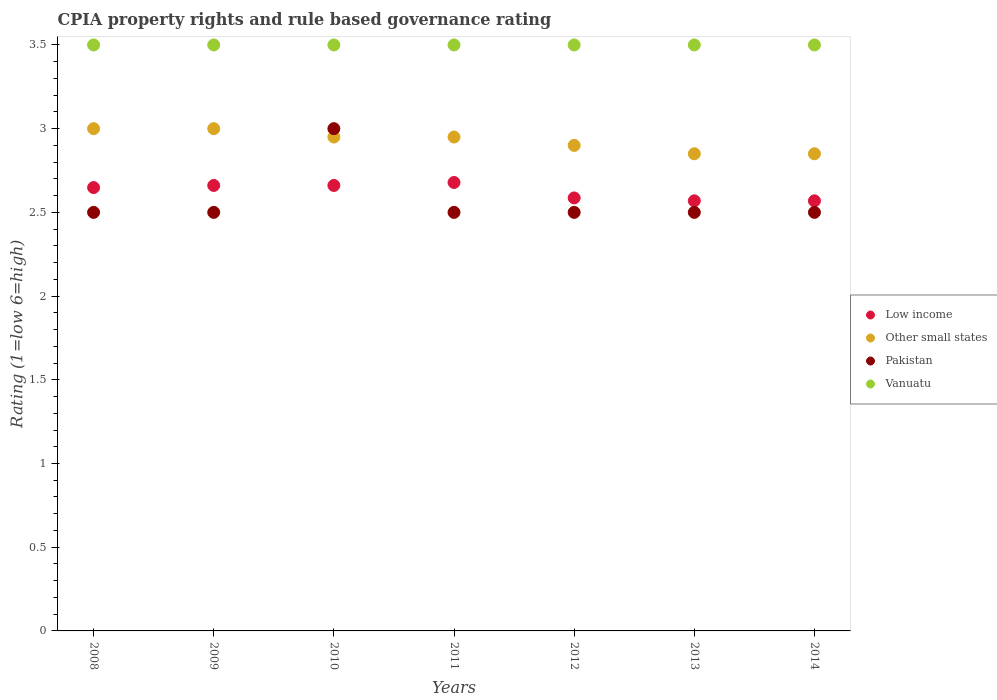How many different coloured dotlines are there?
Provide a short and direct response. 4. What is the CPIA rating in Pakistan in 2010?
Give a very brief answer. 3. Across all years, what is the maximum CPIA rating in Other small states?
Ensure brevity in your answer.  3. What is the total CPIA rating in Pakistan in the graph?
Your answer should be compact. 18. What is the difference between the CPIA rating in Low income in 2009 and that in 2011?
Make the answer very short. -0.02. What is the difference between the CPIA rating in Pakistan in 2013 and the CPIA rating in Vanuatu in 2009?
Offer a terse response. -1. What is the average CPIA rating in Pakistan per year?
Ensure brevity in your answer.  2.57. What is the difference between the highest and the second highest CPIA rating in Pakistan?
Your response must be concise. 0.5. What is the difference between the highest and the lowest CPIA rating in Pakistan?
Your answer should be very brief. 0.5. In how many years, is the CPIA rating in Vanuatu greater than the average CPIA rating in Vanuatu taken over all years?
Provide a short and direct response. 0. Is the sum of the CPIA rating in Vanuatu in 2009 and 2010 greater than the maximum CPIA rating in Other small states across all years?
Provide a succinct answer. Yes. Is the CPIA rating in Vanuatu strictly greater than the CPIA rating in Low income over the years?
Ensure brevity in your answer.  Yes. How many dotlines are there?
Provide a short and direct response. 4. Does the graph contain any zero values?
Offer a terse response. No. Where does the legend appear in the graph?
Your answer should be compact. Center right. How many legend labels are there?
Offer a very short reply. 4. How are the legend labels stacked?
Make the answer very short. Vertical. What is the title of the graph?
Keep it short and to the point. CPIA property rights and rule based governance rating. Does "Togo" appear as one of the legend labels in the graph?
Give a very brief answer. No. What is the label or title of the X-axis?
Provide a succinct answer. Years. What is the label or title of the Y-axis?
Your answer should be very brief. Rating (1=low 6=high). What is the Rating (1=low 6=high) of Low income in 2008?
Keep it short and to the point. 2.65. What is the Rating (1=low 6=high) of Vanuatu in 2008?
Ensure brevity in your answer.  3.5. What is the Rating (1=low 6=high) in Low income in 2009?
Your response must be concise. 2.66. What is the Rating (1=low 6=high) in Pakistan in 2009?
Your answer should be compact. 2.5. What is the Rating (1=low 6=high) of Low income in 2010?
Offer a very short reply. 2.66. What is the Rating (1=low 6=high) in Other small states in 2010?
Give a very brief answer. 2.95. What is the Rating (1=low 6=high) of Pakistan in 2010?
Keep it short and to the point. 3. What is the Rating (1=low 6=high) in Low income in 2011?
Provide a short and direct response. 2.68. What is the Rating (1=low 6=high) of Other small states in 2011?
Provide a short and direct response. 2.95. What is the Rating (1=low 6=high) of Pakistan in 2011?
Give a very brief answer. 2.5. What is the Rating (1=low 6=high) in Vanuatu in 2011?
Your answer should be compact. 3.5. What is the Rating (1=low 6=high) in Low income in 2012?
Your answer should be compact. 2.59. What is the Rating (1=low 6=high) of Other small states in 2012?
Ensure brevity in your answer.  2.9. What is the Rating (1=low 6=high) of Pakistan in 2012?
Make the answer very short. 2.5. What is the Rating (1=low 6=high) of Vanuatu in 2012?
Keep it short and to the point. 3.5. What is the Rating (1=low 6=high) of Low income in 2013?
Make the answer very short. 2.57. What is the Rating (1=low 6=high) of Other small states in 2013?
Keep it short and to the point. 2.85. What is the Rating (1=low 6=high) of Pakistan in 2013?
Your answer should be compact. 2.5. What is the Rating (1=low 6=high) of Low income in 2014?
Your answer should be very brief. 2.57. What is the Rating (1=low 6=high) in Other small states in 2014?
Provide a short and direct response. 2.85. Across all years, what is the maximum Rating (1=low 6=high) in Low income?
Offer a terse response. 2.68. Across all years, what is the maximum Rating (1=low 6=high) of Vanuatu?
Offer a very short reply. 3.5. Across all years, what is the minimum Rating (1=low 6=high) in Low income?
Provide a short and direct response. 2.57. Across all years, what is the minimum Rating (1=low 6=high) of Other small states?
Your answer should be very brief. 2.85. Across all years, what is the minimum Rating (1=low 6=high) in Pakistan?
Offer a terse response. 2.5. Across all years, what is the minimum Rating (1=low 6=high) in Vanuatu?
Provide a succinct answer. 3.5. What is the total Rating (1=low 6=high) of Low income in the graph?
Your answer should be compact. 18.37. What is the total Rating (1=low 6=high) in Vanuatu in the graph?
Provide a short and direct response. 24.5. What is the difference between the Rating (1=low 6=high) of Low income in 2008 and that in 2009?
Your answer should be compact. -0.01. What is the difference between the Rating (1=low 6=high) in Other small states in 2008 and that in 2009?
Give a very brief answer. 0. What is the difference between the Rating (1=low 6=high) in Pakistan in 2008 and that in 2009?
Provide a succinct answer. 0. What is the difference between the Rating (1=low 6=high) of Low income in 2008 and that in 2010?
Your answer should be compact. -0.01. What is the difference between the Rating (1=low 6=high) of Vanuatu in 2008 and that in 2010?
Provide a short and direct response. 0. What is the difference between the Rating (1=low 6=high) in Low income in 2008 and that in 2011?
Your response must be concise. -0.03. What is the difference between the Rating (1=low 6=high) in Low income in 2008 and that in 2012?
Keep it short and to the point. 0.06. What is the difference between the Rating (1=low 6=high) of Other small states in 2008 and that in 2012?
Your response must be concise. 0.1. What is the difference between the Rating (1=low 6=high) in Pakistan in 2008 and that in 2012?
Provide a short and direct response. 0. What is the difference between the Rating (1=low 6=high) of Low income in 2008 and that in 2013?
Your answer should be very brief. 0.08. What is the difference between the Rating (1=low 6=high) in Other small states in 2008 and that in 2013?
Make the answer very short. 0.15. What is the difference between the Rating (1=low 6=high) in Pakistan in 2008 and that in 2013?
Offer a terse response. 0. What is the difference between the Rating (1=low 6=high) in Vanuatu in 2008 and that in 2013?
Provide a short and direct response. 0. What is the difference between the Rating (1=low 6=high) of Low income in 2008 and that in 2014?
Your answer should be compact. 0.08. What is the difference between the Rating (1=low 6=high) in Pakistan in 2008 and that in 2014?
Make the answer very short. 0. What is the difference between the Rating (1=low 6=high) in Pakistan in 2009 and that in 2010?
Ensure brevity in your answer.  -0.5. What is the difference between the Rating (1=low 6=high) of Low income in 2009 and that in 2011?
Provide a succinct answer. -0.02. What is the difference between the Rating (1=low 6=high) of Low income in 2009 and that in 2012?
Offer a terse response. 0.07. What is the difference between the Rating (1=low 6=high) of Vanuatu in 2009 and that in 2012?
Ensure brevity in your answer.  0. What is the difference between the Rating (1=low 6=high) of Low income in 2009 and that in 2013?
Offer a very short reply. 0.09. What is the difference between the Rating (1=low 6=high) in Other small states in 2009 and that in 2013?
Offer a terse response. 0.15. What is the difference between the Rating (1=low 6=high) in Low income in 2009 and that in 2014?
Offer a very short reply. 0.09. What is the difference between the Rating (1=low 6=high) of Pakistan in 2009 and that in 2014?
Your answer should be compact. 0. What is the difference between the Rating (1=low 6=high) of Low income in 2010 and that in 2011?
Keep it short and to the point. -0.02. What is the difference between the Rating (1=low 6=high) of Other small states in 2010 and that in 2011?
Your answer should be very brief. 0. What is the difference between the Rating (1=low 6=high) of Vanuatu in 2010 and that in 2011?
Keep it short and to the point. 0. What is the difference between the Rating (1=low 6=high) of Low income in 2010 and that in 2012?
Give a very brief answer. 0.07. What is the difference between the Rating (1=low 6=high) in Other small states in 2010 and that in 2012?
Provide a succinct answer. 0.05. What is the difference between the Rating (1=low 6=high) of Pakistan in 2010 and that in 2012?
Offer a terse response. 0.5. What is the difference between the Rating (1=low 6=high) in Vanuatu in 2010 and that in 2012?
Keep it short and to the point. 0. What is the difference between the Rating (1=low 6=high) in Low income in 2010 and that in 2013?
Ensure brevity in your answer.  0.09. What is the difference between the Rating (1=low 6=high) in Other small states in 2010 and that in 2013?
Provide a short and direct response. 0.1. What is the difference between the Rating (1=low 6=high) of Vanuatu in 2010 and that in 2013?
Your answer should be compact. 0. What is the difference between the Rating (1=low 6=high) in Low income in 2010 and that in 2014?
Your answer should be compact. 0.09. What is the difference between the Rating (1=low 6=high) in Other small states in 2010 and that in 2014?
Offer a very short reply. 0.1. What is the difference between the Rating (1=low 6=high) in Pakistan in 2010 and that in 2014?
Provide a succinct answer. 0.5. What is the difference between the Rating (1=low 6=high) in Low income in 2011 and that in 2012?
Offer a terse response. 0.09. What is the difference between the Rating (1=low 6=high) of Other small states in 2011 and that in 2012?
Your answer should be compact. 0.05. What is the difference between the Rating (1=low 6=high) in Low income in 2011 and that in 2013?
Keep it short and to the point. 0.11. What is the difference between the Rating (1=low 6=high) in Pakistan in 2011 and that in 2013?
Ensure brevity in your answer.  0. What is the difference between the Rating (1=low 6=high) in Vanuatu in 2011 and that in 2013?
Your response must be concise. 0. What is the difference between the Rating (1=low 6=high) in Low income in 2011 and that in 2014?
Ensure brevity in your answer.  0.11. What is the difference between the Rating (1=low 6=high) in Vanuatu in 2011 and that in 2014?
Provide a short and direct response. 0. What is the difference between the Rating (1=low 6=high) in Low income in 2012 and that in 2013?
Your answer should be very brief. 0.02. What is the difference between the Rating (1=low 6=high) in Other small states in 2012 and that in 2013?
Your response must be concise. 0.05. What is the difference between the Rating (1=low 6=high) of Pakistan in 2012 and that in 2013?
Provide a succinct answer. 0. What is the difference between the Rating (1=low 6=high) in Vanuatu in 2012 and that in 2013?
Your answer should be compact. 0. What is the difference between the Rating (1=low 6=high) in Low income in 2012 and that in 2014?
Your answer should be compact. 0.02. What is the difference between the Rating (1=low 6=high) in Pakistan in 2012 and that in 2014?
Provide a succinct answer. 0. What is the difference between the Rating (1=low 6=high) of Vanuatu in 2012 and that in 2014?
Your answer should be compact. 0. What is the difference between the Rating (1=low 6=high) of Other small states in 2013 and that in 2014?
Provide a succinct answer. 0. What is the difference between the Rating (1=low 6=high) of Pakistan in 2013 and that in 2014?
Offer a very short reply. 0. What is the difference between the Rating (1=low 6=high) of Low income in 2008 and the Rating (1=low 6=high) of Other small states in 2009?
Your answer should be compact. -0.35. What is the difference between the Rating (1=low 6=high) in Low income in 2008 and the Rating (1=low 6=high) in Pakistan in 2009?
Keep it short and to the point. 0.15. What is the difference between the Rating (1=low 6=high) in Low income in 2008 and the Rating (1=low 6=high) in Vanuatu in 2009?
Your response must be concise. -0.85. What is the difference between the Rating (1=low 6=high) of Other small states in 2008 and the Rating (1=low 6=high) of Vanuatu in 2009?
Keep it short and to the point. -0.5. What is the difference between the Rating (1=low 6=high) in Low income in 2008 and the Rating (1=low 6=high) in Other small states in 2010?
Give a very brief answer. -0.3. What is the difference between the Rating (1=low 6=high) of Low income in 2008 and the Rating (1=low 6=high) of Pakistan in 2010?
Offer a terse response. -0.35. What is the difference between the Rating (1=low 6=high) in Low income in 2008 and the Rating (1=low 6=high) in Vanuatu in 2010?
Make the answer very short. -0.85. What is the difference between the Rating (1=low 6=high) in Low income in 2008 and the Rating (1=low 6=high) in Other small states in 2011?
Provide a succinct answer. -0.3. What is the difference between the Rating (1=low 6=high) in Low income in 2008 and the Rating (1=low 6=high) in Pakistan in 2011?
Your answer should be very brief. 0.15. What is the difference between the Rating (1=low 6=high) of Low income in 2008 and the Rating (1=low 6=high) of Vanuatu in 2011?
Keep it short and to the point. -0.85. What is the difference between the Rating (1=low 6=high) of Pakistan in 2008 and the Rating (1=low 6=high) of Vanuatu in 2011?
Give a very brief answer. -1. What is the difference between the Rating (1=low 6=high) in Low income in 2008 and the Rating (1=low 6=high) in Other small states in 2012?
Your answer should be very brief. -0.25. What is the difference between the Rating (1=low 6=high) of Low income in 2008 and the Rating (1=low 6=high) of Pakistan in 2012?
Make the answer very short. 0.15. What is the difference between the Rating (1=low 6=high) in Low income in 2008 and the Rating (1=low 6=high) in Vanuatu in 2012?
Offer a terse response. -0.85. What is the difference between the Rating (1=low 6=high) of Other small states in 2008 and the Rating (1=low 6=high) of Vanuatu in 2012?
Offer a very short reply. -0.5. What is the difference between the Rating (1=low 6=high) of Pakistan in 2008 and the Rating (1=low 6=high) of Vanuatu in 2012?
Ensure brevity in your answer.  -1. What is the difference between the Rating (1=low 6=high) of Low income in 2008 and the Rating (1=low 6=high) of Other small states in 2013?
Keep it short and to the point. -0.2. What is the difference between the Rating (1=low 6=high) in Low income in 2008 and the Rating (1=low 6=high) in Pakistan in 2013?
Keep it short and to the point. 0.15. What is the difference between the Rating (1=low 6=high) in Low income in 2008 and the Rating (1=low 6=high) in Vanuatu in 2013?
Provide a succinct answer. -0.85. What is the difference between the Rating (1=low 6=high) of Pakistan in 2008 and the Rating (1=low 6=high) of Vanuatu in 2013?
Ensure brevity in your answer.  -1. What is the difference between the Rating (1=low 6=high) in Low income in 2008 and the Rating (1=low 6=high) in Other small states in 2014?
Make the answer very short. -0.2. What is the difference between the Rating (1=low 6=high) of Low income in 2008 and the Rating (1=low 6=high) of Pakistan in 2014?
Your answer should be very brief. 0.15. What is the difference between the Rating (1=low 6=high) of Low income in 2008 and the Rating (1=low 6=high) of Vanuatu in 2014?
Your answer should be compact. -0.85. What is the difference between the Rating (1=low 6=high) of Other small states in 2008 and the Rating (1=low 6=high) of Pakistan in 2014?
Ensure brevity in your answer.  0.5. What is the difference between the Rating (1=low 6=high) in Other small states in 2008 and the Rating (1=low 6=high) in Vanuatu in 2014?
Offer a very short reply. -0.5. What is the difference between the Rating (1=low 6=high) of Low income in 2009 and the Rating (1=low 6=high) of Other small states in 2010?
Provide a succinct answer. -0.29. What is the difference between the Rating (1=low 6=high) in Low income in 2009 and the Rating (1=low 6=high) in Pakistan in 2010?
Provide a short and direct response. -0.34. What is the difference between the Rating (1=low 6=high) in Low income in 2009 and the Rating (1=low 6=high) in Vanuatu in 2010?
Make the answer very short. -0.84. What is the difference between the Rating (1=low 6=high) of Other small states in 2009 and the Rating (1=low 6=high) of Pakistan in 2010?
Your response must be concise. 0. What is the difference between the Rating (1=low 6=high) of Low income in 2009 and the Rating (1=low 6=high) of Other small states in 2011?
Your answer should be compact. -0.29. What is the difference between the Rating (1=low 6=high) of Low income in 2009 and the Rating (1=low 6=high) of Pakistan in 2011?
Provide a succinct answer. 0.16. What is the difference between the Rating (1=low 6=high) of Low income in 2009 and the Rating (1=low 6=high) of Vanuatu in 2011?
Provide a short and direct response. -0.84. What is the difference between the Rating (1=low 6=high) in Other small states in 2009 and the Rating (1=low 6=high) in Pakistan in 2011?
Give a very brief answer. 0.5. What is the difference between the Rating (1=low 6=high) in Low income in 2009 and the Rating (1=low 6=high) in Other small states in 2012?
Keep it short and to the point. -0.24. What is the difference between the Rating (1=low 6=high) of Low income in 2009 and the Rating (1=low 6=high) of Pakistan in 2012?
Provide a short and direct response. 0.16. What is the difference between the Rating (1=low 6=high) in Low income in 2009 and the Rating (1=low 6=high) in Vanuatu in 2012?
Your response must be concise. -0.84. What is the difference between the Rating (1=low 6=high) of Low income in 2009 and the Rating (1=low 6=high) of Other small states in 2013?
Offer a terse response. -0.19. What is the difference between the Rating (1=low 6=high) in Low income in 2009 and the Rating (1=low 6=high) in Pakistan in 2013?
Ensure brevity in your answer.  0.16. What is the difference between the Rating (1=low 6=high) of Low income in 2009 and the Rating (1=low 6=high) of Vanuatu in 2013?
Keep it short and to the point. -0.84. What is the difference between the Rating (1=low 6=high) in Other small states in 2009 and the Rating (1=low 6=high) in Pakistan in 2013?
Offer a very short reply. 0.5. What is the difference between the Rating (1=low 6=high) of Pakistan in 2009 and the Rating (1=low 6=high) of Vanuatu in 2013?
Give a very brief answer. -1. What is the difference between the Rating (1=low 6=high) of Low income in 2009 and the Rating (1=low 6=high) of Other small states in 2014?
Give a very brief answer. -0.19. What is the difference between the Rating (1=low 6=high) of Low income in 2009 and the Rating (1=low 6=high) of Pakistan in 2014?
Offer a terse response. 0.16. What is the difference between the Rating (1=low 6=high) of Low income in 2009 and the Rating (1=low 6=high) of Vanuatu in 2014?
Provide a succinct answer. -0.84. What is the difference between the Rating (1=low 6=high) in Other small states in 2009 and the Rating (1=low 6=high) in Pakistan in 2014?
Provide a short and direct response. 0.5. What is the difference between the Rating (1=low 6=high) in Low income in 2010 and the Rating (1=low 6=high) in Other small states in 2011?
Your response must be concise. -0.29. What is the difference between the Rating (1=low 6=high) in Low income in 2010 and the Rating (1=low 6=high) in Pakistan in 2011?
Offer a terse response. 0.16. What is the difference between the Rating (1=low 6=high) in Low income in 2010 and the Rating (1=low 6=high) in Vanuatu in 2011?
Your answer should be very brief. -0.84. What is the difference between the Rating (1=low 6=high) in Other small states in 2010 and the Rating (1=low 6=high) in Pakistan in 2011?
Your answer should be very brief. 0.45. What is the difference between the Rating (1=low 6=high) in Other small states in 2010 and the Rating (1=low 6=high) in Vanuatu in 2011?
Your answer should be compact. -0.55. What is the difference between the Rating (1=low 6=high) of Low income in 2010 and the Rating (1=low 6=high) of Other small states in 2012?
Offer a very short reply. -0.24. What is the difference between the Rating (1=low 6=high) of Low income in 2010 and the Rating (1=low 6=high) of Pakistan in 2012?
Your answer should be very brief. 0.16. What is the difference between the Rating (1=low 6=high) of Low income in 2010 and the Rating (1=low 6=high) of Vanuatu in 2012?
Your answer should be compact. -0.84. What is the difference between the Rating (1=low 6=high) in Other small states in 2010 and the Rating (1=low 6=high) in Pakistan in 2012?
Offer a terse response. 0.45. What is the difference between the Rating (1=low 6=high) in Other small states in 2010 and the Rating (1=low 6=high) in Vanuatu in 2012?
Offer a terse response. -0.55. What is the difference between the Rating (1=low 6=high) of Pakistan in 2010 and the Rating (1=low 6=high) of Vanuatu in 2012?
Keep it short and to the point. -0.5. What is the difference between the Rating (1=low 6=high) of Low income in 2010 and the Rating (1=low 6=high) of Other small states in 2013?
Make the answer very short. -0.19. What is the difference between the Rating (1=low 6=high) of Low income in 2010 and the Rating (1=low 6=high) of Pakistan in 2013?
Offer a very short reply. 0.16. What is the difference between the Rating (1=low 6=high) in Low income in 2010 and the Rating (1=low 6=high) in Vanuatu in 2013?
Give a very brief answer. -0.84. What is the difference between the Rating (1=low 6=high) in Other small states in 2010 and the Rating (1=low 6=high) in Pakistan in 2013?
Your answer should be very brief. 0.45. What is the difference between the Rating (1=low 6=high) in Other small states in 2010 and the Rating (1=low 6=high) in Vanuatu in 2013?
Your response must be concise. -0.55. What is the difference between the Rating (1=low 6=high) of Pakistan in 2010 and the Rating (1=low 6=high) of Vanuatu in 2013?
Your answer should be very brief. -0.5. What is the difference between the Rating (1=low 6=high) of Low income in 2010 and the Rating (1=low 6=high) of Other small states in 2014?
Offer a terse response. -0.19. What is the difference between the Rating (1=low 6=high) in Low income in 2010 and the Rating (1=low 6=high) in Pakistan in 2014?
Offer a very short reply. 0.16. What is the difference between the Rating (1=low 6=high) of Low income in 2010 and the Rating (1=low 6=high) of Vanuatu in 2014?
Give a very brief answer. -0.84. What is the difference between the Rating (1=low 6=high) of Other small states in 2010 and the Rating (1=low 6=high) of Pakistan in 2014?
Your response must be concise. 0.45. What is the difference between the Rating (1=low 6=high) of Other small states in 2010 and the Rating (1=low 6=high) of Vanuatu in 2014?
Give a very brief answer. -0.55. What is the difference between the Rating (1=low 6=high) of Low income in 2011 and the Rating (1=low 6=high) of Other small states in 2012?
Offer a terse response. -0.22. What is the difference between the Rating (1=low 6=high) of Low income in 2011 and the Rating (1=low 6=high) of Pakistan in 2012?
Provide a succinct answer. 0.18. What is the difference between the Rating (1=low 6=high) in Low income in 2011 and the Rating (1=low 6=high) in Vanuatu in 2012?
Provide a succinct answer. -0.82. What is the difference between the Rating (1=low 6=high) in Other small states in 2011 and the Rating (1=low 6=high) in Pakistan in 2012?
Make the answer very short. 0.45. What is the difference between the Rating (1=low 6=high) of Other small states in 2011 and the Rating (1=low 6=high) of Vanuatu in 2012?
Ensure brevity in your answer.  -0.55. What is the difference between the Rating (1=low 6=high) in Pakistan in 2011 and the Rating (1=low 6=high) in Vanuatu in 2012?
Give a very brief answer. -1. What is the difference between the Rating (1=low 6=high) in Low income in 2011 and the Rating (1=low 6=high) in Other small states in 2013?
Your answer should be compact. -0.17. What is the difference between the Rating (1=low 6=high) in Low income in 2011 and the Rating (1=low 6=high) in Pakistan in 2013?
Keep it short and to the point. 0.18. What is the difference between the Rating (1=low 6=high) in Low income in 2011 and the Rating (1=low 6=high) in Vanuatu in 2013?
Give a very brief answer. -0.82. What is the difference between the Rating (1=low 6=high) of Other small states in 2011 and the Rating (1=low 6=high) of Pakistan in 2013?
Offer a very short reply. 0.45. What is the difference between the Rating (1=low 6=high) of Other small states in 2011 and the Rating (1=low 6=high) of Vanuatu in 2013?
Your answer should be very brief. -0.55. What is the difference between the Rating (1=low 6=high) in Low income in 2011 and the Rating (1=low 6=high) in Other small states in 2014?
Give a very brief answer. -0.17. What is the difference between the Rating (1=low 6=high) of Low income in 2011 and the Rating (1=low 6=high) of Pakistan in 2014?
Your answer should be compact. 0.18. What is the difference between the Rating (1=low 6=high) of Low income in 2011 and the Rating (1=low 6=high) of Vanuatu in 2014?
Give a very brief answer. -0.82. What is the difference between the Rating (1=low 6=high) of Other small states in 2011 and the Rating (1=low 6=high) of Pakistan in 2014?
Offer a very short reply. 0.45. What is the difference between the Rating (1=low 6=high) of Other small states in 2011 and the Rating (1=low 6=high) of Vanuatu in 2014?
Provide a short and direct response. -0.55. What is the difference between the Rating (1=low 6=high) in Pakistan in 2011 and the Rating (1=low 6=high) in Vanuatu in 2014?
Offer a very short reply. -1. What is the difference between the Rating (1=low 6=high) of Low income in 2012 and the Rating (1=low 6=high) of Other small states in 2013?
Ensure brevity in your answer.  -0.26. What is the difference between the Rating (1=low 6=high) of Low income in 2012 and the Rating (1=low 6=high) of Pakistan in 2013?
Offer a terse response. 0.09. What is the difference between the Rating (1=low 6=high) of Low income in 2012 and the Rating (1=low 6=high) of Vanuatu in 2013?
Provide a short and direct response. -0.91. What is the difference between the Rating (1=low 6=high) of Other small states in 2012 and the Rating (1=low 6=high) of Pakistan in 2013?
Make the answer very short. 0.4. What is the difference between the Rating (1=low 6=high) in Low income in 2012 and the Rating (1=low 6=high) in Other small states in 2014?
Give a very brief answer. -0.26. What is the difference between the Rating (1=low 6=high) of Low income in 2012 and the Rating (1=low 6=high) of Pakistan in 2014?
Offer a terse response. 0.09. What is the difference between the Rating (1=low 6=high) in Low income in 2012 and the Rating (1=low 6=high) in Vanuatu in 2014?
Your answer should be compact. -0.91. What is the difference between the Rating (1=low 6=high) of Other small states in 2012 and the Rating (1=low 6=high) of Vanuatu in 2014?
Offer a terse response. -0.6. What is the difference between the Rating (1=low 6=high) of Low income in 2013 and the Rating (1=low 6=high) of Other small states in 2014?
Offer a terse response. -0.28. What is the difference between the Rating (1=low 6=high) in Low income in 2013 and the Rating (1=low 6=high) in Pakistan in 2014?
Make the answer very short. 0.07. What is the difference between the Rating (1=low 6=high) of Low income in 2013 and the Rating (1=low 6=high) of Vanuatu in 2014?
Your response must be concise. -0.93. What is the difference between the Rating (1=low 6=high) of Other small states in 2013 and the Rating (1=low 6=high) of Vanuatu in 2014?
Your response must be concise. -0.65. What is the average Rating (1=low 6=high) of Low income per year?
Provide a short and direct response. 2.62. What is the average Rating (1=low 6=high) of Other small states per year?
Give a very brief answer. 2.93. What is the average Rating (1=low 6=high) in Pakistan per year?
Make the answer very short. 2.57. In the year 2008, what is the difference between the Rating (1=low 6=high) in Low income and Rating (1=low 6=high) in Other small states?
Keep it short and to the point. -0.35. In the year 2008, what is the difference between the Rating (1=low 6=high) in Low income and Rating (1=low 6=high) in Pakistan?
Ensure brevity in your answer.  0.15. In the year 2008, what is the difference between the Rating (1=low 6=high) of Low income and Rating (1=low 6=high) of Vanuatu?
Your response must be concise. -0.85. In the year 2009, what is the difference between the Rating (1=low 6=high) in Low income and Rating (1=low 6=high) in Other small states?
Ensure brevity in your answer.  -0.34. In the year 2009, what is the difference between the Rating (1=low 6=high) in Low income and Rating (1=low 6=high) in Pakistan?
Provide a short and direct response. 0.16. In the year 2009, what is the difference between the Rating (1=low 6=high) of Low income and Rating (1=low 6=high) of Vanuatu?
Offer a terse response. -0.84. In the year 2009, what is the difference between the Rating (1=low 6=high) in Other small states and Rating (1=low 6=high) in Pakistan?
Provide a succinct answer. 0.5. In the year 2009, what is the difference between the Rating (1=low 6=high) in Other small states and Rating (1=low 6=high) in Vanuatu?
Offer a terse response. -0.5. In the year 2010, what is the difference between the Rating (1=low 6=high) in Low income and Rating (1=low 6=high) in Other small states?
Your answer should be very brief. -0.29. In the year 2010, what is the difference between the Rating (1=low 6=high) in Low income and Rating (1=low 6=high) in Pakistan?
Your answer should be very brief. -0.34. In the year 2010, what is the difference between the Rating (1=low 6=high) of Low income and Rating (1=low 6=high) of Vanuatu?
Provide a short and direct response. -0.84. In the year 2010, what is the difference between the Rating (1=low 6=high) of Other small states and Rating (1=low 6=high) of Pakistan?
Your response must be concise. -0.05. In the year 2010, what is the difference between the Rating (1=low 6=high) in Other small states and Rating (1=low 6=high) in Vanuatu?
Ensure brevity in your answer.  -0.55. In the year 2011, what is the difference between the Rating (1=low 6=high) of Low income and Rating (1=low 6=high) of Other small states?
Your response must be concise. -0.27. In the year 2011, what is the difference between the Rating (1=low 6=high) of Low income and Rating (1=low 6=high) of Pakistan?
Your answer should be very brief. 0.18. In the year 2011, what is the difference between the Rating (1=low 6=high) in Low income and Rating (1=low 6=high) in Vanuatu?
Offer a terse response. -0.82. In the year 2011, what is the difference between the Rating (1=low 6=high) of Other small states and Rating (1=low 6=high) of Pakistan?
Keep it short and to the point. 0.45. In the year 2011, what is the difference between the Rating (1=low 6=high) in Other small states and Rating (1=low 6=high) in Vanuatu?
Provide a succinct answer. -0.55. In the year 2011, what is the difference between the Rating (1=low 6=high) of Pakistan and Rating (1=low 6=high) of Vanuatu?
Keep it short and to the point. -1. In the year 2012, what is the difference between the Rating (1=low 6=high) of Low income and Rating (1=low 6=high) of Other small states?
Your answer should be very brief. -0.31. In the year 2012, what is the difference between the Rating (1=low 6=high) of Low income and Rating (1=low 6=high) of Pakistan?
Offer a very short reply. 0.09. In the year 2012, what is the difference between the Rating (1=low 6=high) of Low income and Rating (1=low 6=high) of Vanuatu?
Ensure brevity in your answer.  -0.91. In the year 2012, what is the difference between the Rating (1=low 6=high) of Other small states and Rating (1=low 6=high) of Pakistan?
Your response must be concise. 0.4. In the year 2012, what is the difference between the Rating (1=low 6=high) in Other small states and Rating (1=low 6=high) in Vanuatu?
Give a very brief answer. -0.6. In the year 2012, what is the difference between the Rating (1=low 6=high) in Pakistan and Rating (1=low 6=high) in Vanuatu?
Provide a short and direct response. -1. In the year 2013, what is the difference between the Rating (1=low 6=high) in Low income and Rating (1=low 6=high) in Other small states?
Your answer should be compact. -0.28. In the year 2013, what is the difference between the Rating (1=low 6=high) of Low income and Rating (1=low 6=high) of Pakistan?
Provide a succinct answer. 0.07. In the year 2013, what is the difference between the Rating (1=low 6=high) in Low income and Rating (1=low 6=high) in Vanuatu?
Offer a very short reply. -0.93. In the year 2013, what is the difference between the Rating (1=low 6=high) in Other small states and Rating (1=low 6=high) in Vanuatu?
Give a very brief answer. -0.65. In the year 2014, what is the difference between the Rating (1=low 6=high) of Low income and Rating (1=low 6=high) of Other small states?
Offer a terse response. -0.28. In the year 2014, what is the difference between the Rating (1=low 6=high) in Low income and Rating (1=low 6=high) in Pakistan?
Ensure brevity in your answer.  0.07. In the year 2014, what is the difference between the Rating (1=low 6=high) in Low income and Rating (1=low 6=high) in Vanuatu?
Your response must be concise. -0.93. In the year 2014, what is the difference between the Rating (1=low 6=high) in Other small states and Rating (1=low 6=high) in Vanuatu?
Ensure brevity in your answer.  -0.65. In the year 2014, what is the difference between the Rating (1=low 6=high) of Pakistan and Rating (1=low 6=high) of Vanuatu?
Your response must be concise. -1. What is the ratio of the Rating (1=low 6=high) in Other small states in 2008 to that in 2009?
Keep it short and to the point. 1. What is the ratio of the Rating (1=low 6=high) of Vanuatu in 2008 to that in 2009?
Your answer should be compact. 1. What is the ratio of the Rating (1=low 6=high) in Other small states in 2008 to that in 2010?
Offer a very short reply. 1.02. What is the ratio of the Rating (1=low 6=high) in Vanuatu in 2008 to that in 2010?
Make the answer very short. 1. What is the ratio of the Rating (1=low 6=high) in Low income in 2008 to that in 2011?
Provide a short and direct response. 0.99. What is the ratio of the Rating (1=low 6=high) of Other small states in 2008 to that in 2011?
Make the answer very short. 1.02. What is the ratio of the Rating (1=low 6=high) of Other small states in 2008 to that in 2012?
Your response must be concise. 1.03. What is the ratio of the Rating (1=low 6=high) of Low income in 2008 to that in 2013?
Provide a succinct answer. 1.03. What is the ratio of the Rating (1=low 6=high) in Other small states in 2008 to that in 2013?
Make the answer very short. 1.05. What is the ratio of the Rating (1=low 6=high) in Vanuatu in 2008 to that in 2013?
Provide a succinct answer. 1. What is the ratio of the Rating (1=low 6=high) of Low income in 2008 to that in 2014?
Provide a succinct answer. 1.03. What is the ratio of the Rating (1=low 6=high) of Other small states in 2008 to that in 2014?
Your answer should be compact. 1.05. What is the ratio of the Rating (1=low 6=high) of Pakistan in 2008 to that in 2014?
Your answer should be very brief. 1. What is the ratio of the Rating (1=low 6=high) of Low income in 2009 to that in 2010?
Provide a succinct answer. 1. What is the ratio of the Rating (1=low 6=high) in Other small states in 2009 to that in 2010?
Your response must be concise. 1.02. What is the ratio of the Rating (1=low 6=high) of Pakistan in 2009 to that in 2010?
Offer a terse response. 0.83. What is the ratio of the Rating (1=low 6=high) of Vanuatu in 2009 to that in 2010?
Give a very brief answer. 1. What is the ratio of the Rating (1=low 6=high) in Low income in 2009 to that in 2011?
Give a very brief answer. 0.99. What is the ratio of the Rating (1=low 6=high) of Other small states in 2009 to that in 2011?
Give a very brief answer. 1.02. What is the ratio of the Rating (1=low 6=high) in Vanuatu in 2009 to that in 2011?
Your answer should be compact. 1. What is the ratio of the Rating (1=low 6=high) of Low income in 2009 to that in 2012?
Offer a very short reply. 1.03. What is the ratio of the Rating (1=low 6=high) in Other small states in 2009 to that in 2012?
Ensure brevity in your answer.  1.03. What is the ratio of the Rating (1=low 6=high) in Pakistan in 2009 to that in 2012?
Offer a terse response. 1. What is the ratio of the Rating (1=low 6=high) of Vanuatu in 2009 to that in 2012?
Offer a very short reply. 1. What is the ratio of the Rating (1=low 6=high) of Low income in 2009 to that in 2013?
Your answer should be very brief. 1.04. What is the ratio of the Rating (1=low 6=high) of Other small states in 2009 to that in 2013?
Offer a terse response. 1.05. What is the ratio of the Rating (1=low 6=high) of Pakistan in 2009 to that in 2013?
Your response must be concise. 1. What is the ratio of the Rating (1=low 6=high) of Low income in 2009 to that in 2014?
Provide a succinct answer. 1.04. What is the ratio of the Rating (1=low 6=high) in Other small states in 2009 to that in 2014?
Offer a terse response. 1.05. What is the ratio of the Rating (1=low 6=high) in Low income in 2010 to that in 2011?
Keep it short and to the point. 0.99. What is the ratio of the Rating (1=low 6=high) in Other small states in 2010 to that in 2011?
Your answer should be very brief. 1. What is the ratio of the Rating (1=low 6=high) of Pakistan in 2010 to that in 2011?
Give a very brief answer. 1.2. What is the ratio of the Rating (1=low 6=high) in Low income in 2010 to that in 2012?
Offer a very short reply. 1.03. What is the ratio of the Rating (1=low 6=high) in Other small states in 2010 to that in 2012?
Keep it short and to the point. 1.02. What is the ratio of the Rating (1=low 6=high) of Pakistan in 2010 to that in 2012?
Provide a succinct answer. 1.2. What is the ratio of the Rating (1=low 6=high) in Vanuatu in 2010 to that in 2012?
Give a very brief answer. 1. What is the ratio of the Rating (1=low 6=high) in Low income in 2010 to that in 2013?
Your answer should be very brief. 1.04. What is the ratio of the Rating (1=low 6=high) in Other small states in 2010 to that in 2013?
Give a very brief answer. 1.04. What is the ratio of the Rating (1=low 6=high) of Vanuatu in 2010 to that in 2013?
Offer a terse response. 1. What is the ratio of the Rating (1=low 6=high) in Low income in 2010 to that in 2014?
Your answer should be very brief. 1.04. What is the ratio of the Rating (1=low 6=high) of Other small states in 2010 to that in 2014?
Your response must be concise. 1.04. What is the ratio of the Rating (1=low 6=high) of Pakistan in 2010 to that in 2014?
Ensure brevity in your answer.  1.2. What is the ratio of the Rating (1=low 6=high) in Vanuatu in 2010 to that in 2014?
Keep it short and to the point. 1. What is the ratio of the Rating (1=low 6=high) of Low income in 2011 to that in 2012?
Your response must be concise. 1.04. What is the ratio of the Rating (1=low 6=high) in Other small states in 2011 to that in 2012?
Ensure brevity in your answer.  1.02. What is the ratio of the Rating (1=low 6=high) in Pakistan in 2011 to that in 2012?
Your response must be concise. 1. What is the ratio of the Rating (1=low 6=high) of Low income in 2011 to that in 2013?
Your response must be concise. 1.04. What is the ratio of the Rating (1=low 6=high) in Other small states in 2011 to that in 2013?
Offer a terse response. 1.04. What is the ratio of the Rating (1=low 6=high) in Pakistan in 2011 to that in 2013?
Ensure brevity in your answer.  1. What is the ratio of the Rating (1=low 6=high) of Vanuatu in 2011 to that in 2013?
Offer a very short reply. 1. What is the ratio of the Rating (1=low 6=high) of Low income in 2011 to that in 2014?
Offer a terse response. 1.04. What is the ratio of the Rating (1=low 6=high) of Other small states in 2011 to that in 2014?
Provide a short and direct response. 1.04. What is the ratio of the Rating (1=low 6=high) of Low income in 2012 to that in 2013?
Offer a terse response. 1.01. What is the ratio of the Rating (1=low 6=high) of Other small states in 2012 to that in 2013?
Provide a succinct answer. 1.02. What is the ratio of the Rating (1=low 6=high) of Vanuatu in 2012 to that in 2013?
Ensure brevity in your answer.  1. What is the ratio of the Rating (1=low 6=high) of Other small states in 2012 to that in 2014?
Your response must be concise. 1.02. What is the ratio of the Rating (1=low 6=high) in Vanuatu in 2012 to that in 2014?
Make the answer very short. 1. What is the ratio of the Rating (1=low 6=high) in Low income in 2013 to that in 2014?
Your answer should be very brief. 1. What is the difference between the highest and the second highest Rating (1=low 6=high) in Low income?
Ensure brevity in your answer.  0.02. What is the difference between the highest and the second highest Rating (1=low 6=high) in Pakistan?
Keep it short and to the point. 0.5. What is the difference between the highest and the lowest Rating (1=low 6=high) in Low income?
Keep it short and to the point. 0.11. What is the difference between the highest and the lowest Rating (1=low 6=high) of Pakistan?
Provide a short and direct response. 0.5. 